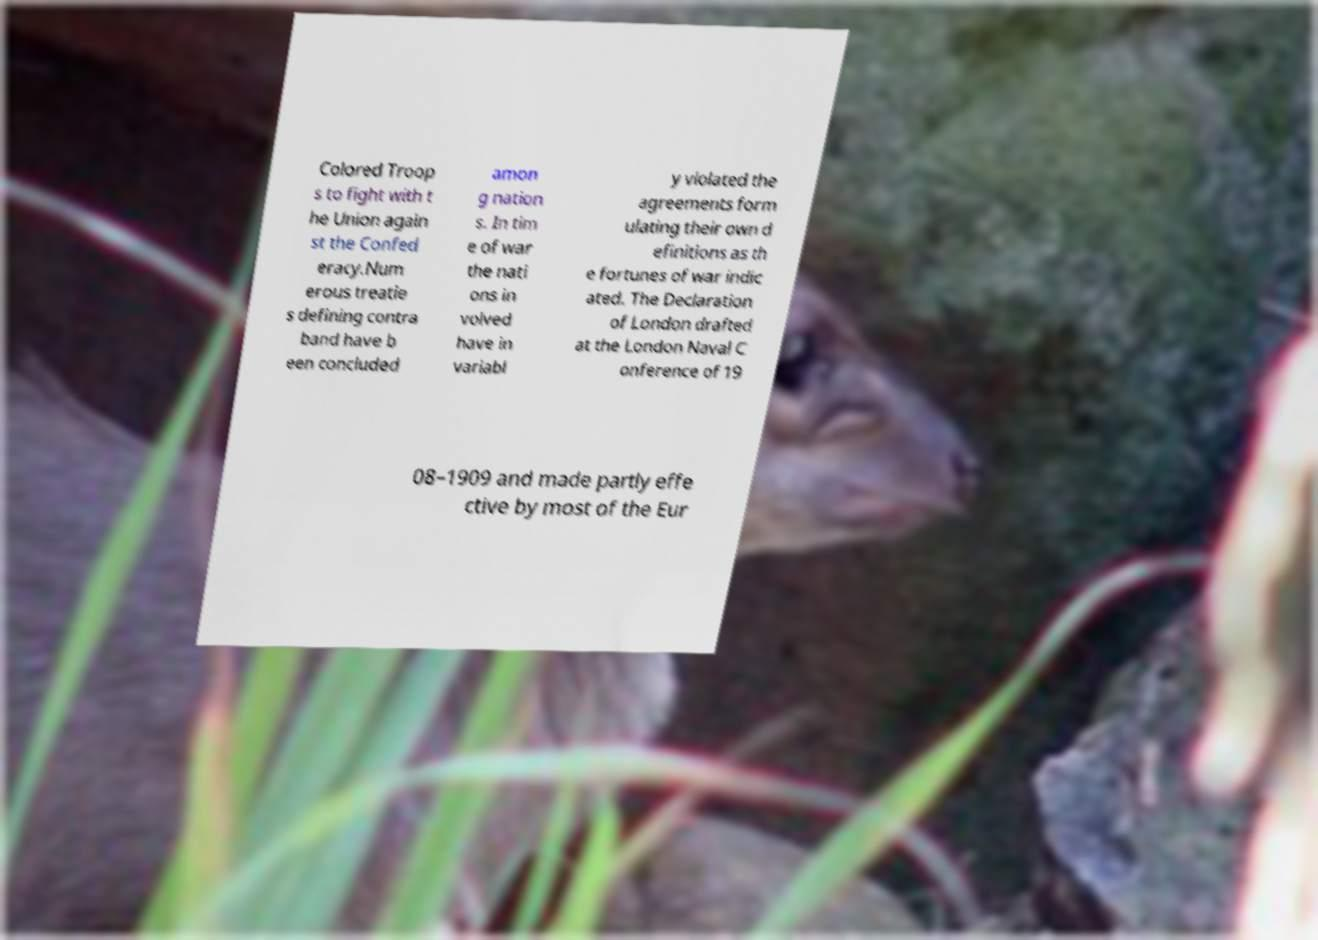Could you extract and type out the text from this image? Colored Troop s to fight with t he Union again st the Confed eracy.Num erous treatie s defining contra band have b een concluded amon g nation s. In tim e of war the nati ons in volved have in variabl y violated the agreements form ulating their own d efinitions as th e fortunes of war indic ated. The Declaration of London drafted at the London Naval C onference of 19 08–1909 and made partly effe ctive by most of the Eur 